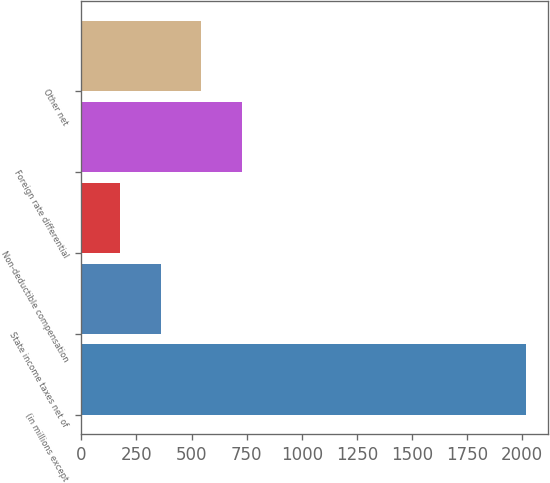Convert chart to OTSL. <chart><loc_0><loc_0><loc_500><loc_500><bar_chart><fcel>(in millions except<fcel>State income taxes net of<fcel>Non-deductible compensation<fcel>Foreign rate differential<fcel>Other net<nl><fcel>2017<fcel>359.2<fcel>175<fcel>727.6<fcel>543.4<nl></chart> 